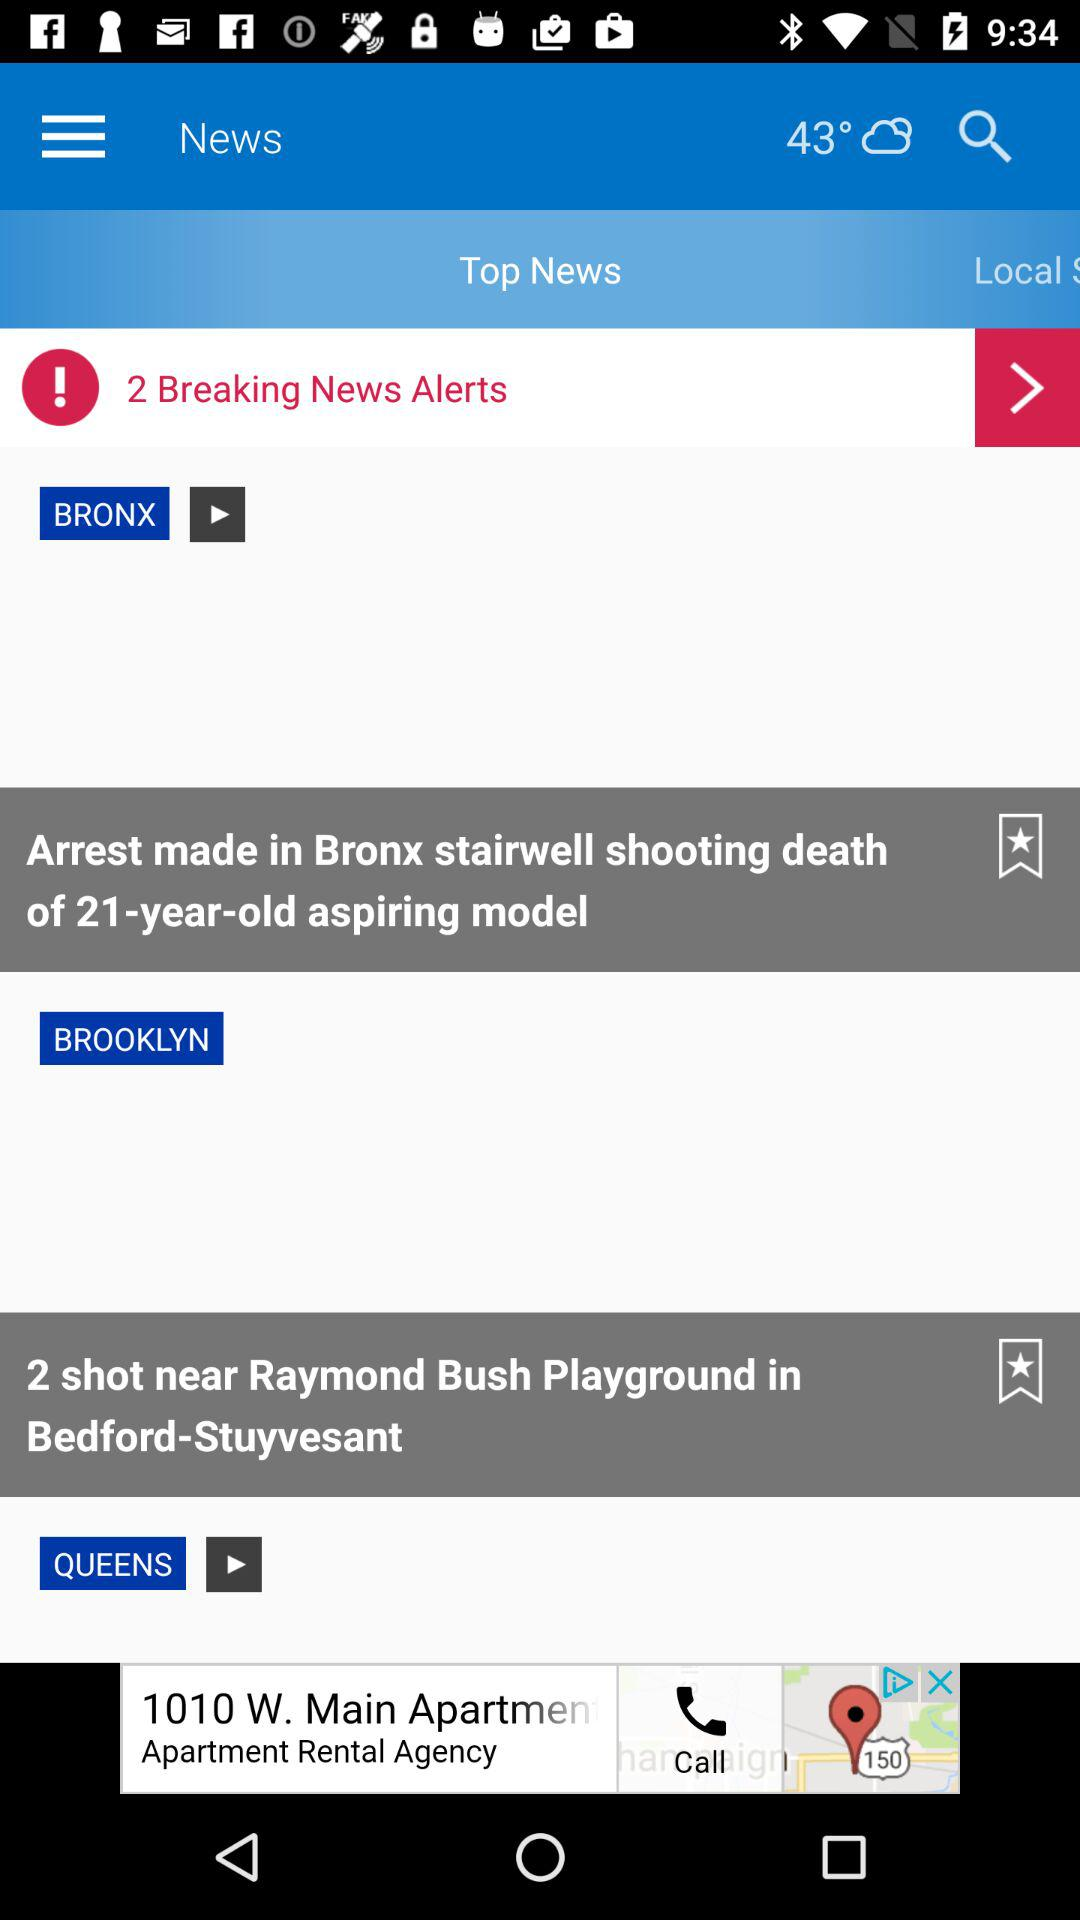How many people are shot near Raymond Bush Playground? The number of people shot near Raymond Blush Playground is 2. 